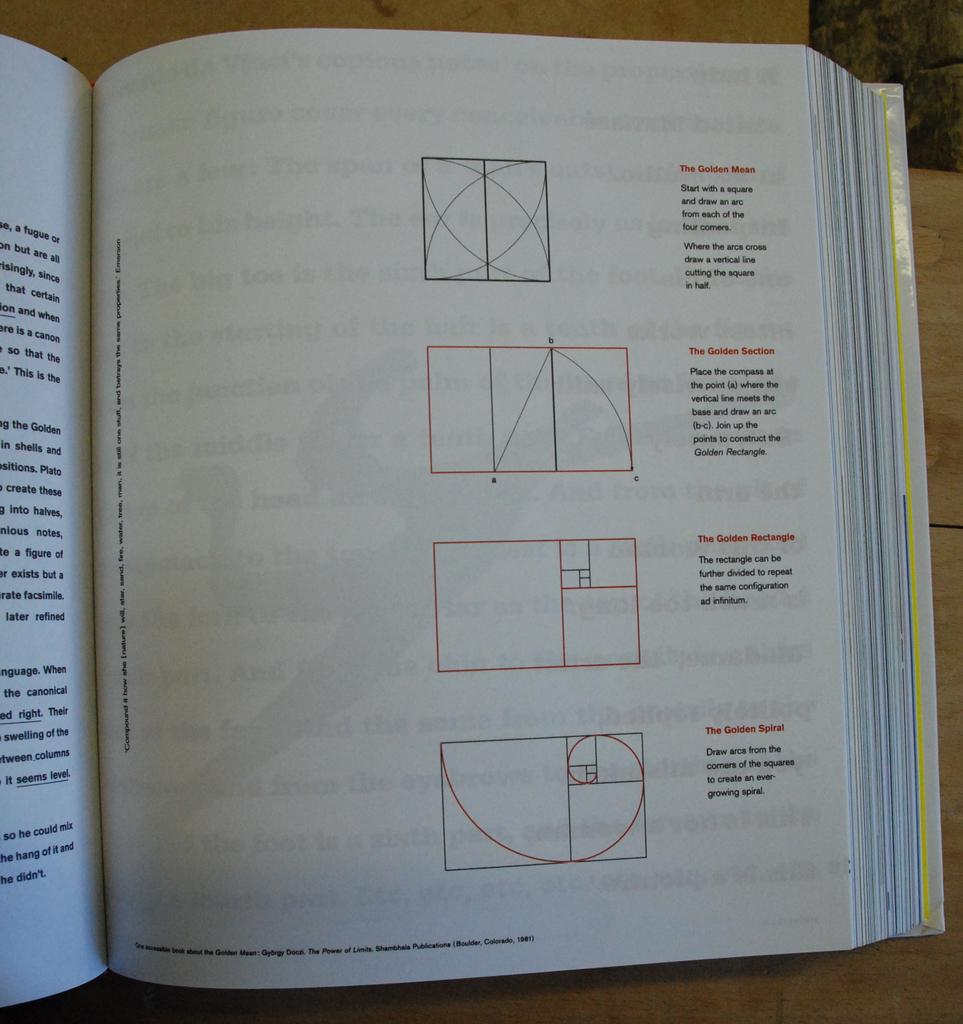<image>
Offer a succinct explanation of the picture presented. A math book opened to the description of The Golden Mean. 